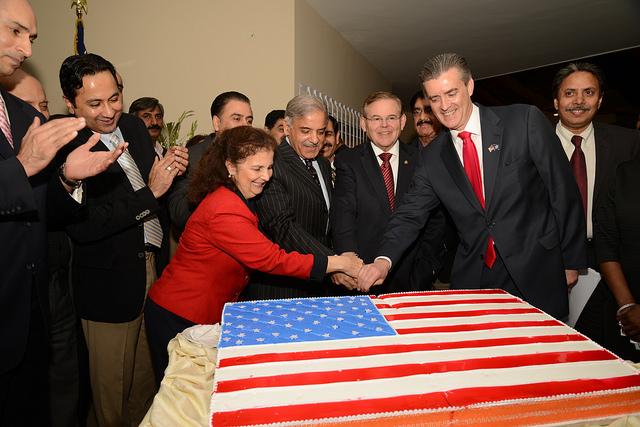Can these cakes feed all these people?
Write a very short answer. Yes. What is the cake decorated to be?
Give a very brief answer. American flag. What season is this?
Be succinct. Fall. What is on the man's head on the right?
Answer briefly. Hair. Are they all friends?
Short answer required. Yes. Are the stripes on the curtain vertical or horizontal?
Keep it brief. Horizontal. What country's flag is that?
Short answer required. Usa. Are there any woman around?
Be succinct. Yes. Has the cake been cut yet?
Quick response, please. No. How many people are wearing orange sweaters?
Keep it brief. 0. 